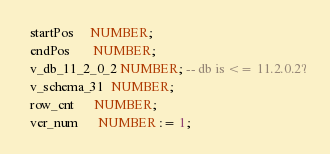<code> <loc_0><loc_0><loc_500><loc_500><_SQL_>  startPos     NUMBER;
  endPos       NUMBER;
  v_db_11_2_0_2 NUMBER; -- db is <= 11.2.0.2?
  v_schema_31  NUMBER;
  row_cnt      NUMBER;
  ver_num      NUMBER := 1;</code> 